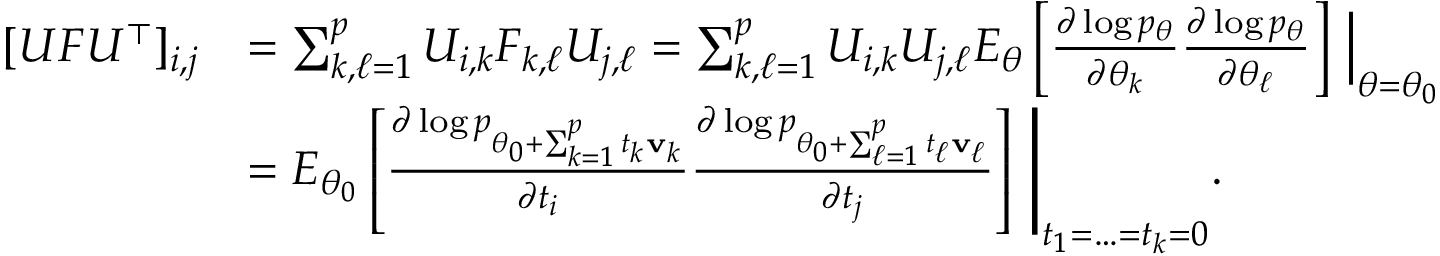Convert formula to latex. <formula><loc_0><loc_0><loc_500><loc_500>\begin{array} { r l } { [ U F U ^ { \top } ] _ { i , j } } & { = \sum _ { k , \ell = 1 } ^ { p } U _ { i , k } F _ { k , \ell } U _ { j , \ell } = \sum _ { k , \ell = 1 } ^ { p } U _ { i , k } U _ { j , \ell } E _ { \theta } \left [ \frac { \partial \log p _ { \theta } } { \partial \theta _ { k } } \frac { \partial \log p _ { \theta } } { \partial \theta _ { \ell } } \right ] \, \left | _ { \theta = \theta _ { 0 } } } \\ & { = E _ { \theta _ { 0 } } \left [ \frac { \partial \log p _ { \theta _ { 0 } + \sum _ { k = 1 } ^ { p } t _ { k } { v } _ { k } } } { \partial t _ { i } } \frac { \partial \log p _ { \theta _ { 0 } + \sum _ { \ell = 1 } ^ { p } t _ { \ell } { v } _ { \ell } } } { \partial t _ { j } } \right ] \, \right | _ { t _ { 1 } = \dots = t _ { k } = 0 } . } \end{array}</formula> 